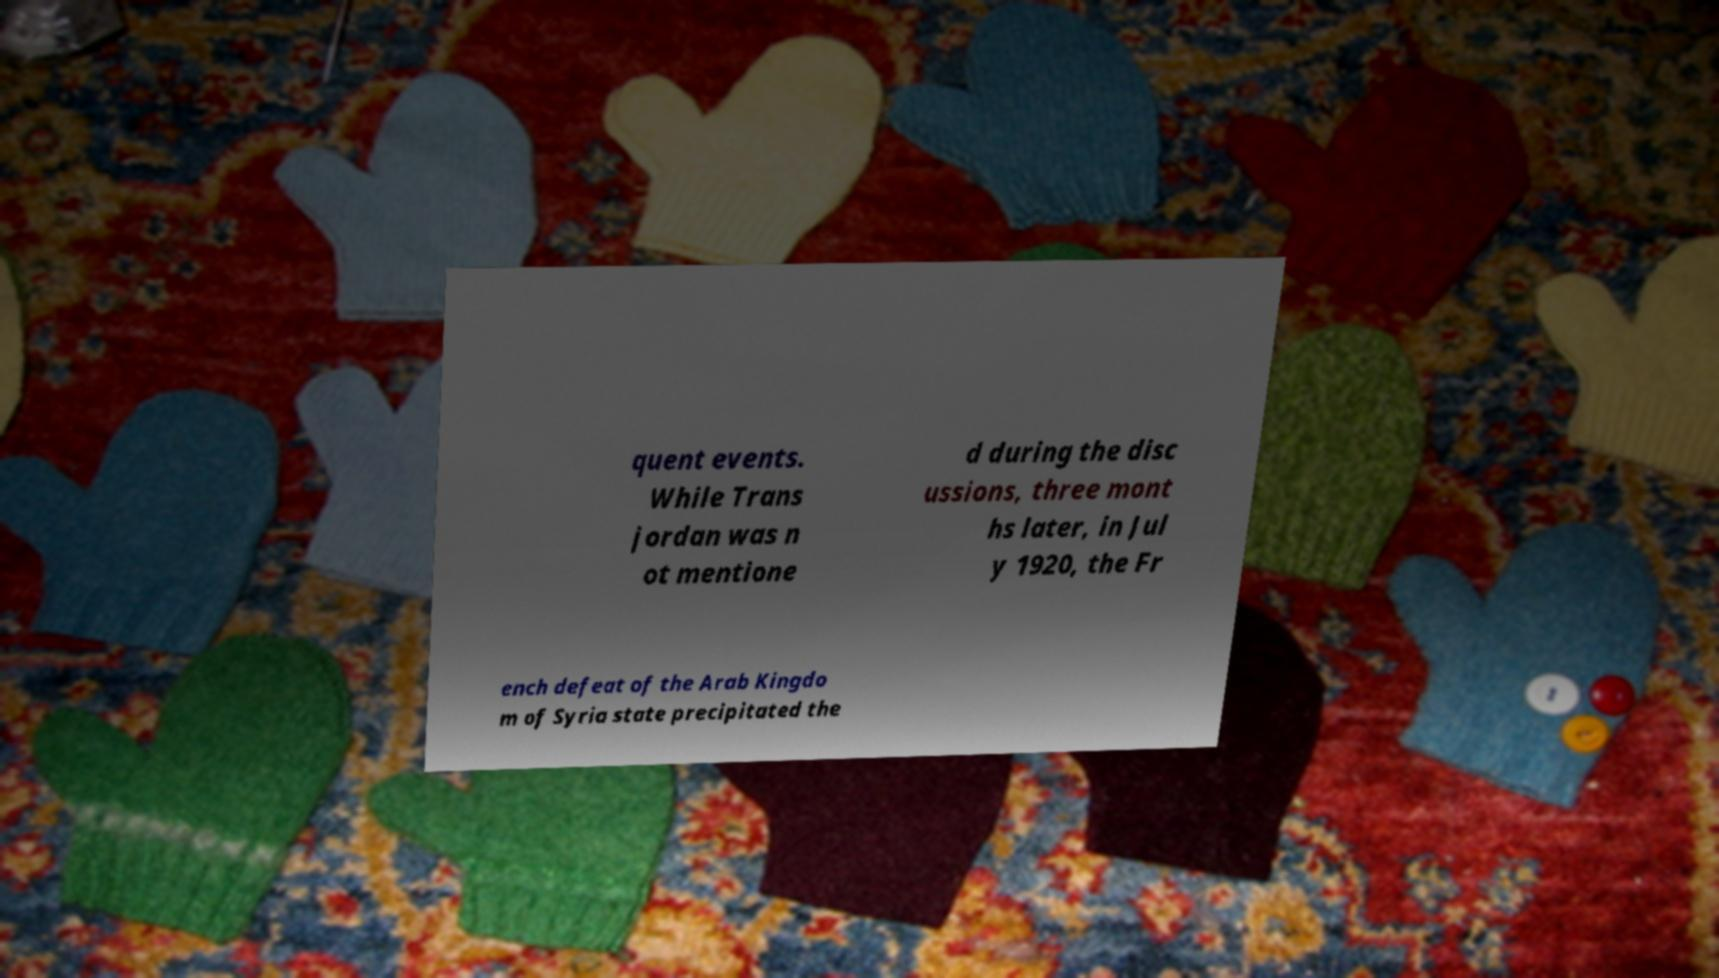I need the written content from this picture converted into text. Can you do that? quent events. While Trans jordan was n ot mentione d during the disc ussions, three mont hs later, in Jul y 1920, the Fr ench defeat of the Arab Kingdo m of Syria state precipitated the 